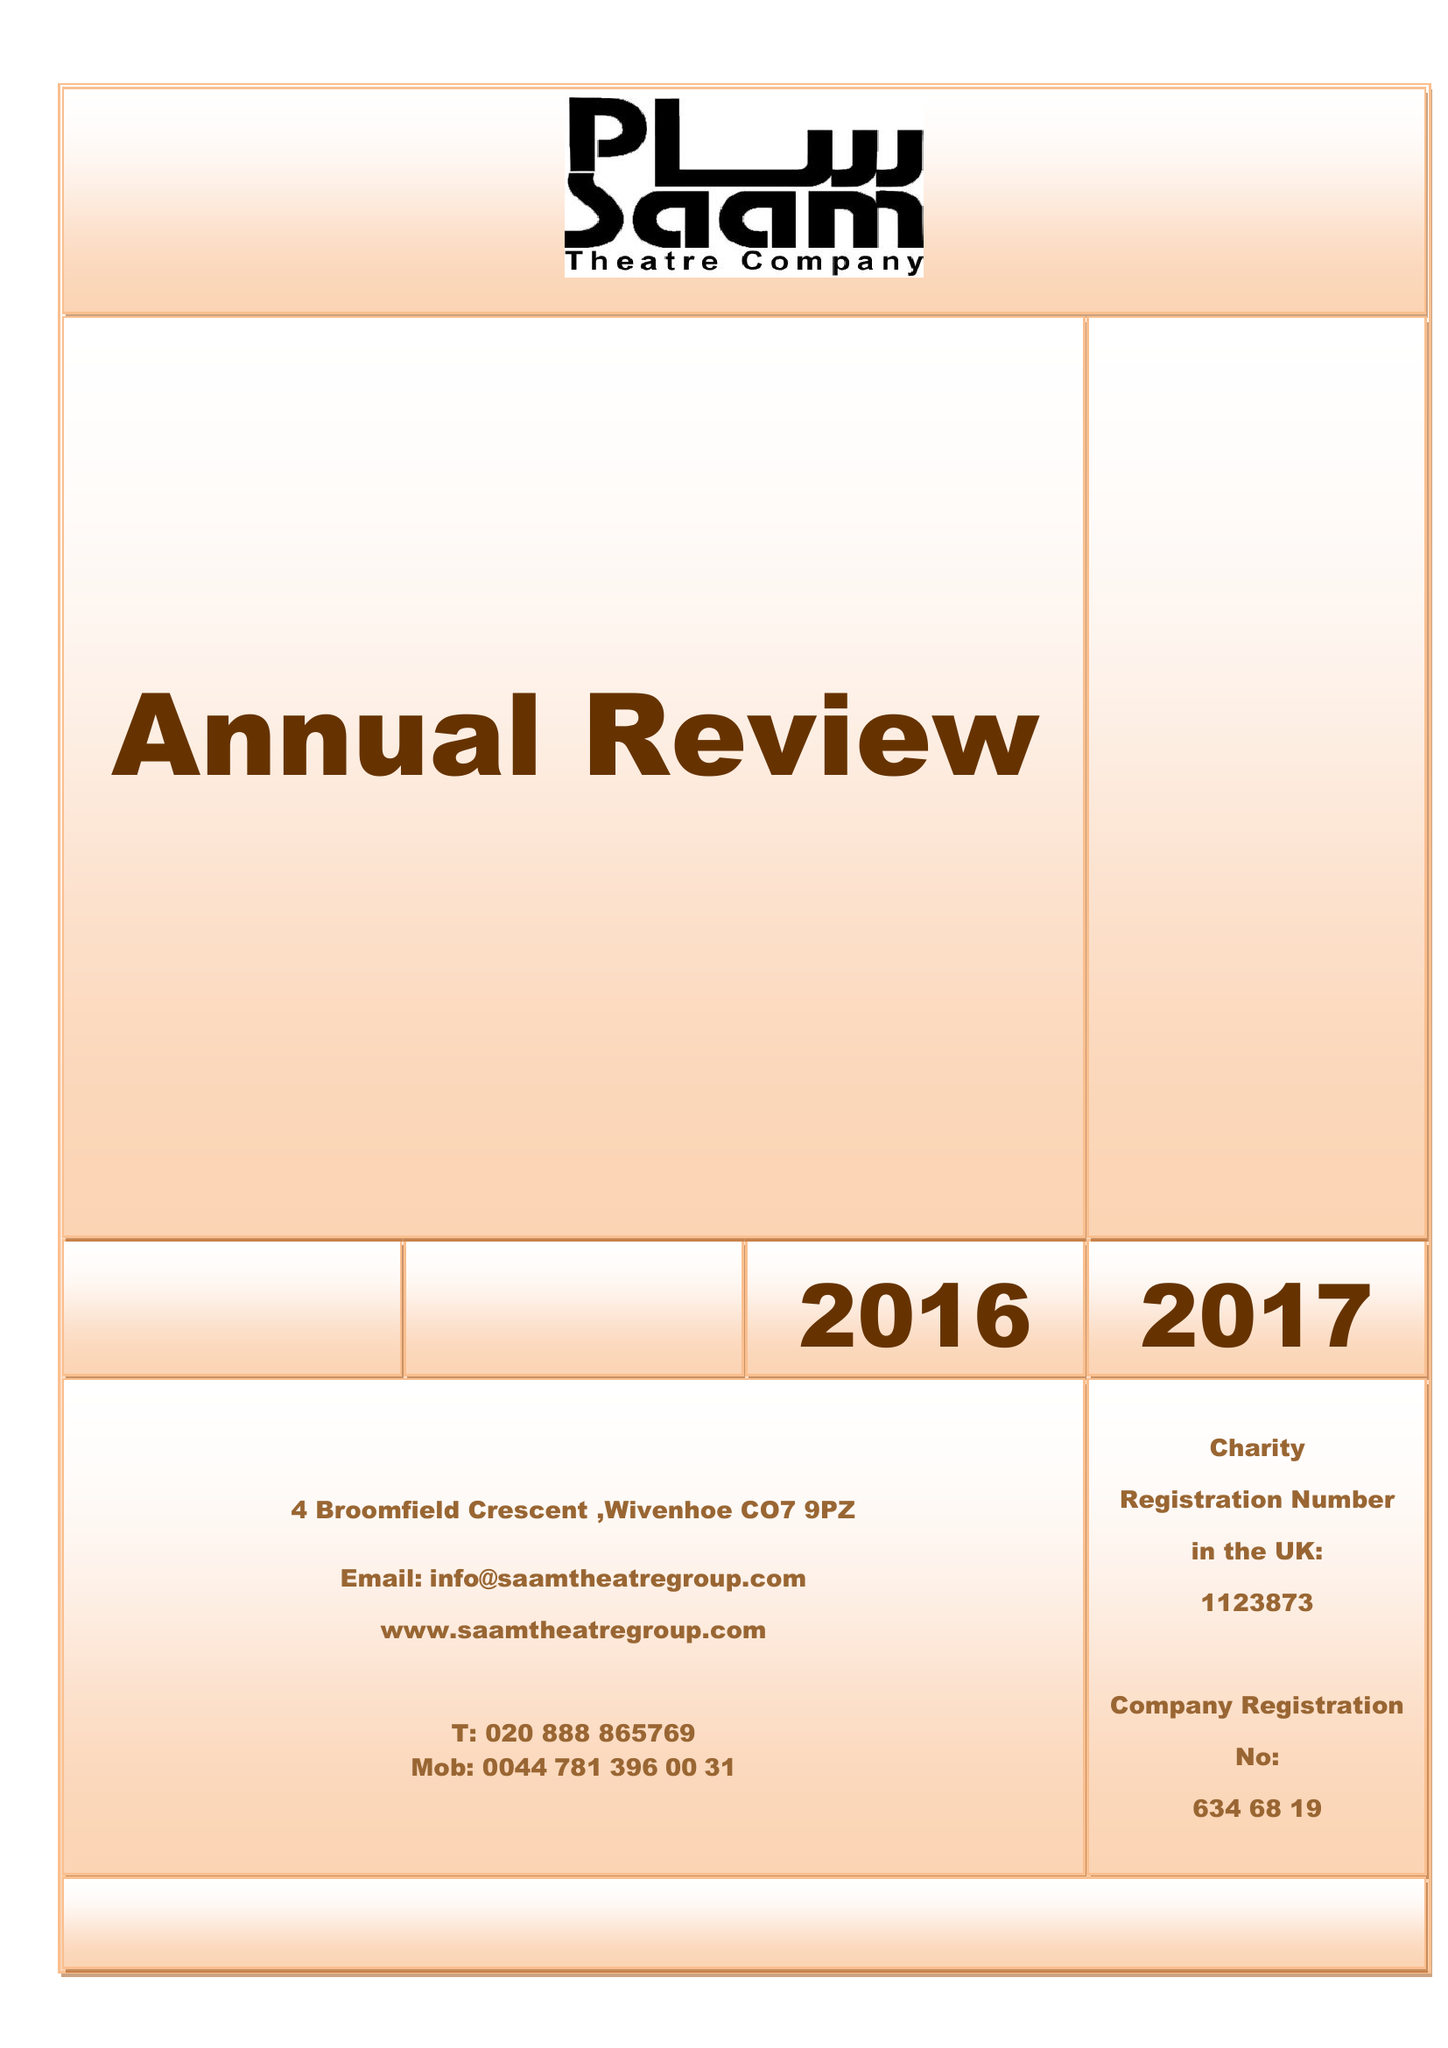What is the value for the address__street_line?
Answer the question using a single word or phrase. None 